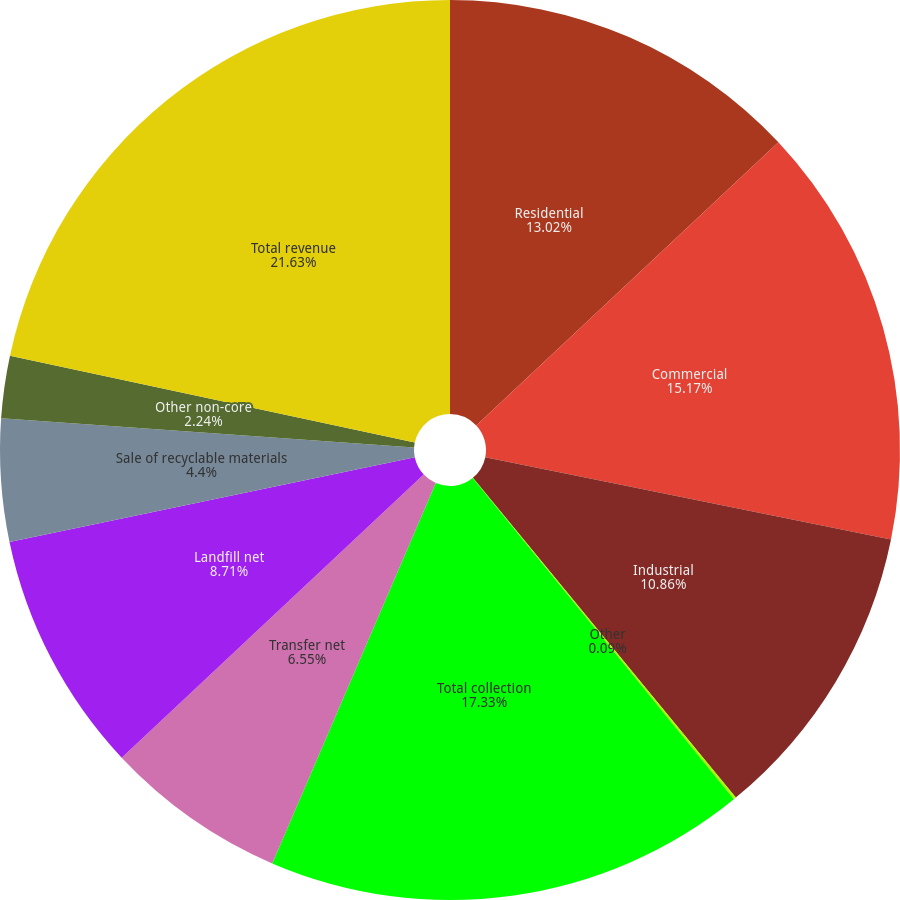Convert chart to OTSL. <chart><loc_0><loc_0><loc_500><loc_500><pie_chart><fcel>Residential<fcel>Commercial<fcel>Industrial<fcel>Other<fcel>Total collection<fcel>Transfer net<fcel>Landfill net<fcel>Sale of recyclable materials<fcel>Other non-core<fcel>Total revenue<nl><fcel>13.02%<fcel>15.17%<fcel>10.86%<fcel>0.09%<fcel>17.33%<fcel>6.55%<fcel>8.71%<fcel>4.4%<fcel>2.24%<fcel>21.64%<nl></chart> 